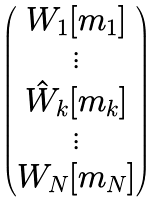Convert formula to latex. <formula><loc_0><loc_0><loc_500><loc_500>\begin{pmatrix} W _ { 1 } [ m _ { 1 } ] \\ \vdots \\ \hat { W } _ { k } [ m _ { k } ] \\ \vdots \\ W _ { N } [ m _ { N } ] \end{pmatrix}</formula> 